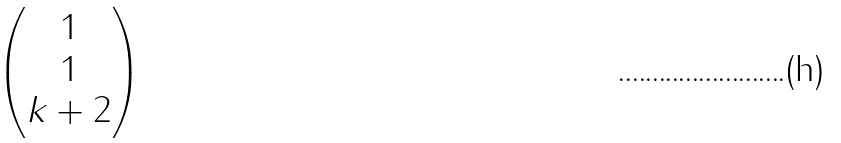<formula> <loc_0><loc_0><loc_500><loc_500>\begin{pmatrix} 1 \\ 1 \\ k + 2 \end{pmatrix}</formula> 